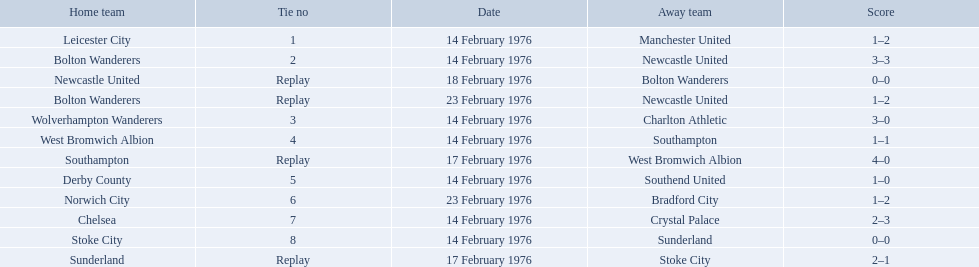Who were all of the teams? Leicester City, Manchester United, Bolton Wanderers, Newcastle United, Newcastle United, Bolton Wanderers, Bolton Wanderers, Newcastle United, Wolverhampton Wanderers, Charlton Athletic, West Bromwich Albion, Southampton, Southampton, West Bromwich Albion, Derby County, Southend United, Norwich City, Bradford City, Chelsea, Crystal Palace, Stoke City, Sunderland, Sunderland, Stoke City. And what were their scores? 1–2, 3–3, 0–0, 1–2, 3–0, 1–1, 4–0, 1–0, 1–2, 2–3, 0–0, 2–1. Between manchester and wolverhampton, who scored more? Wolverhampton Wanderers. Who were all the teams that played? Leicester City, Manchester United, Bolton Wanderers, Newcastle United, Newcastle United, Bolton Wanderers, Bolton Wanderers, Newcastle United, Wolverhampton Wanderers, Charlton Athletic, West Bromwich Albion, Southampton, Southampton, West Bromwich Albion, Derby County, Southend United, Norwich City, Bradford City, Chelsea, Crystal Palace, Stoke City, Sunderland, Sunderland, Stoke City. Which of these teams won? Manchester United, Newcastle United, Wolverhampton Wanderers, Southampton, Derby County, Bradford City, Crystal Palace, Sunderland. What was manchester united's winning score? 1–2. What was the wolverhampton wonders winning score? 3–0. Which of these two teams had the better winning score? Wolverhampton Wanderers. 